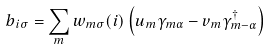<formula> <loc_0><loc_0><loc_500><loc_500>b _ { i \sigma } = \sum _ { m } w _ { m \sigma } ( i ) \left ( u _ { m } \gamma _ { m \alpha } - v _ { m } \gamma _ { m - \alpha } ^ { \dagger } \right )</formula> 